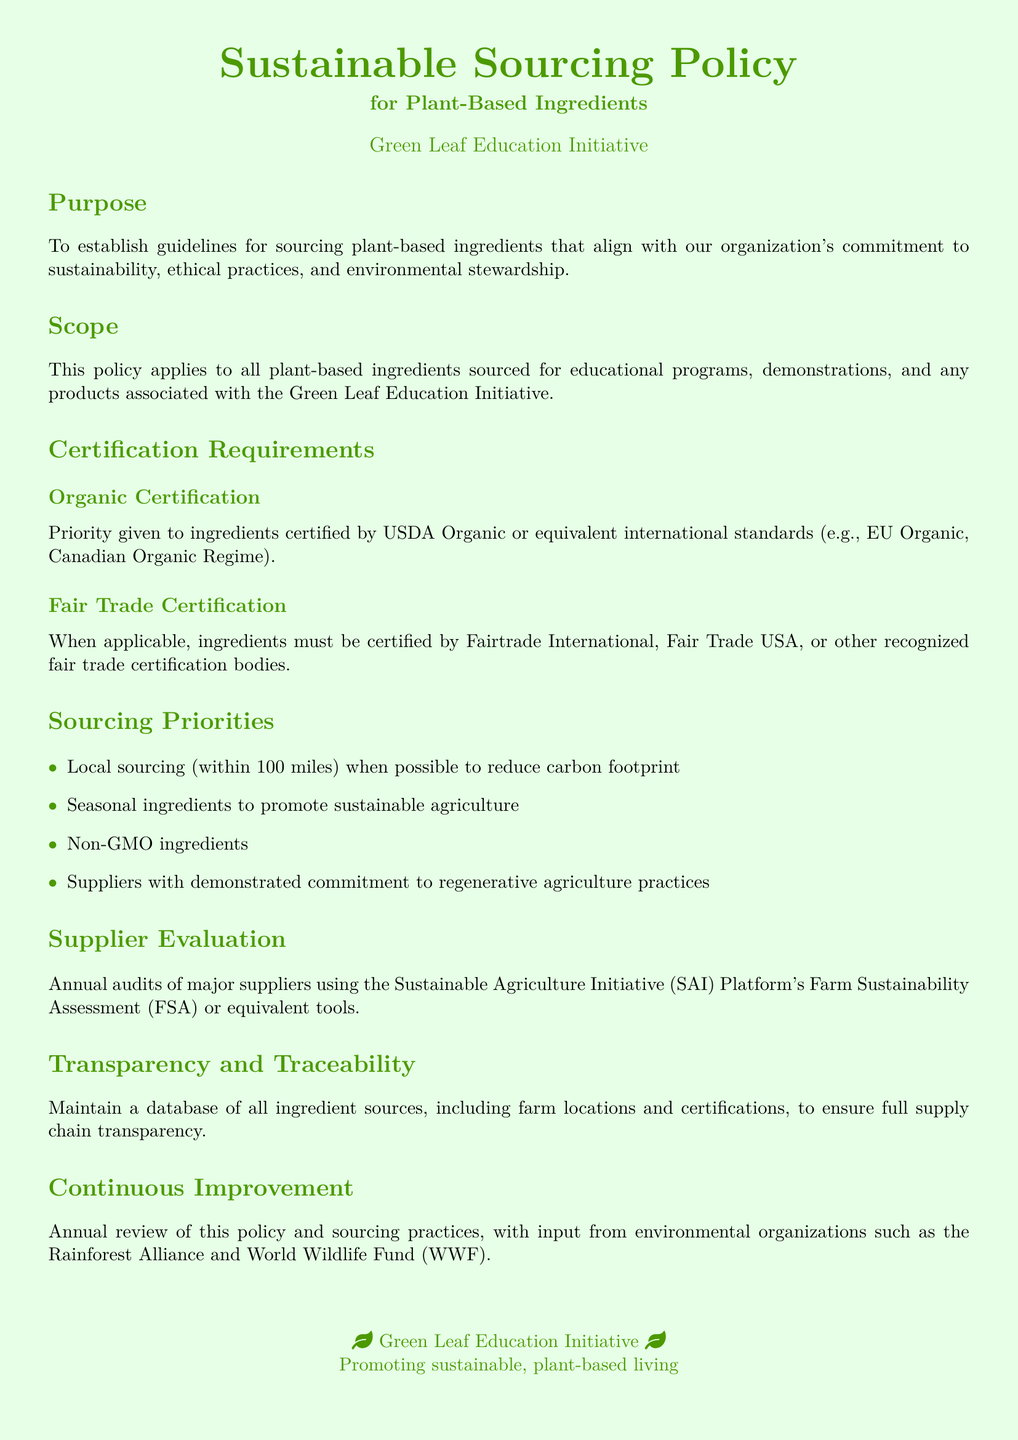What is the priority for organic ingredients? The policy gives priority to ingredients certified by USDA Organic or equivalent international standards.
Answer: USDA Organic What is the maximum distance for local sourcing? The document states that local sourcing is preferred within 100 miles to reduce the carbon footprint.
Answer: 100 miles Which certification is required for fair trade ingredients? Ingredients must be certified by Fairtrade International, Fair Trade USA, or other recognized fair trade certification bodies.
Answer: Fairtrade International What assessment tool is used for supplier evaluation? Major suppliers are evaluated using the Sustainable Agriculture Initiative (SAI) Platform's Farm Sustainability Assessment (FSA) or equivalent tools.
Answer: SAI Platform's Farm Sustainability Assessment How often is the policy reviewed? The document mentions that the policy is reviewed annually.
Answer: Annually What types of ingredients are prioritized for sourcing? The sourcing priorities include local, seasonal, non-GMO ingredients, and those from suppliers committed to regenerative agriculture practices.
Answer: Local, seasonal, non-GMO What is the aim of the policy? The aim is to establish guidelines for sourcing plant-based ingredients that align with sustainability, ethical practices, and environmental stewardship.
Answer: Sustainability, ethical practices, environmental stewardship What does the organization promote? The organization promotes sustainable plant-based living as mentioned at the end of the document.
Answer: Sustainable, plant-based living 